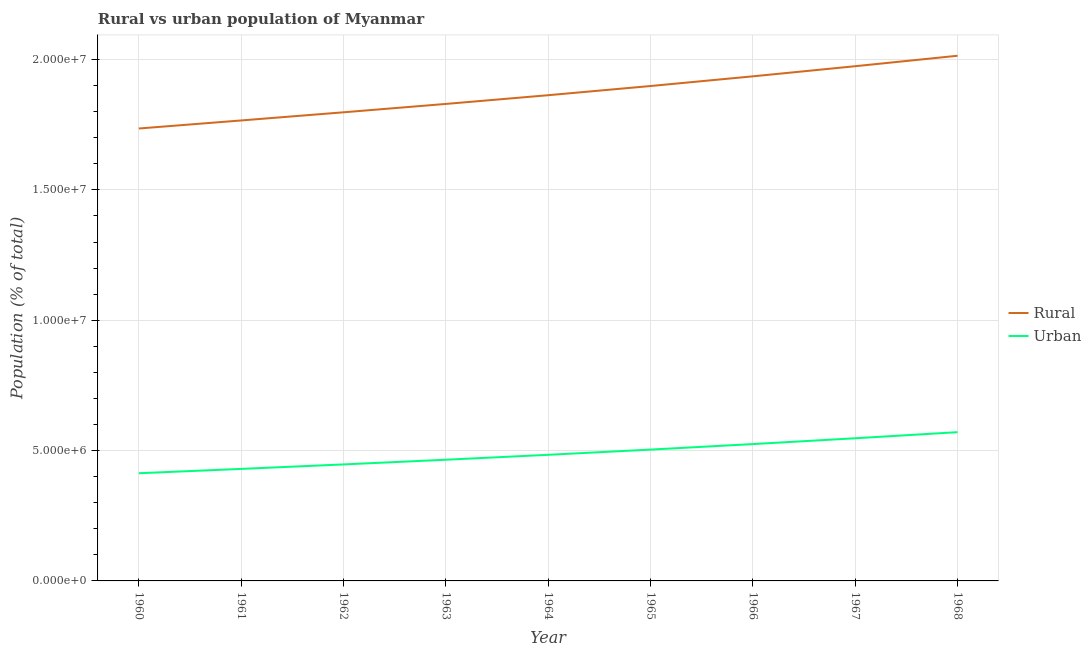Is the number of lines equal to the number of legend labels?
Make the answer very short. Yes. What is the rural population density in 1961?
Your answer should be very brief. 1.77e+07. Across all years, what is the maximum rural population density?
Give a very brief answer. 2.01e+07. Across all years, what is the minimum urban population density?
Keep it short and to the point. 4.13e+06. In which year was the rural population density maximum?
Provide a short and direct response. 1968. What is the total urban population density in the graph?
Give a very brief answer. 4.39e+07. What is the difference between the rural population density in 1964 and that in 1968?
Provide a short and direct response. -1.51e+06. What is the difference between the rural population density in 1967 and the urban population density in 1968?
Provide a succinct answer. 1.40e+07. What is the average urban population density per year?
Offer a terse response. 4.87e+06. In the year 1968, what is the difference between the rural population density and urban population density?
Ensure brevity in your answer.  1.44e+07. What is the ratio of the urban population density in 1960 to that in 1964?
Provide a succinct answer. 0.85. What is the difference between the highest and the second highest urban population density?
Provide a short and direct response. 2.34e+05. What is the difference between the highest and the lowest urban population density?
Provide a succinct answer. 1.58e+06. In how many years, is the urban population density greater than the average urban population density taken over all years?
Keep it short and to the point. 4. Does the rural population density monotonically increase over the years?
Ensure brevity in your answer.  Yes. Is the urban population density strictly greater than the rural population density over the years?
Offer a very short reply. No. What is the difference between two consecutive major ticks on the Y-axis?
Make the answer very short. 5.00e+06. Does the graph contain any zero values?
Offer a very short reply. No. Does the graph contain grids?
Your response must be concise. Yes. How many legend labels are there?
Offer a terse response. 2. How are the legend labels stacked?
Ensure brevity in your answer.  Vertical. What is the title of the graph?
Provide a short and direct response. Rural vs urban population of Myanmar. Does "Official aid received" appear as one of the legend labels in the graph?
Give a very brief answer. No. What is the label or title of the X-axis?
Offer a very short reply. Year. What is the label or title of the Y-axis?
Make the answer very short. Population (% of total). What is the Population (% of total) of Rural in 1960?
Ensure brevity in your answer.  1.74e+07. What is the Population (% of total) of Urban in 1960?
Your answer should be compact. 4.13e+06. What is the Population (% of total) in Rural in 1961?
Offer a very short reply. 1.77e+07. What is the Population (% of total) of Urban in 1961?
Your response must be concise. 4.30e+06. What is the Population (% of total) of Rural in 1962?
Ensure brevity in your answer.  1.80e+07. What is the Population (% of total) of Urban in 1962?
Offer a very short reply. 4.47e+06. What is the Population (% of total) in Rural in 1963?
Ensure brevity in your answer.  1.83e+07. What is the Population (% of total) in Urban in 1963?
Give a very brief answer. 4.65e+06. What is the Population (% of total) of Rural in 1964?
Keep it short and to the point. 1.86e+07. What is the Population (% of total) of Urban in 1964?
Ensure brevity in your answer.  4.84e+06. What is the Population (% of total) of Rural in 1965?
Your response must be concise. 1.90e+07. What is the Population (% of total) in Urban in 1965?
Offer a very short reply. 5.04e+06. What is the Population (% of total) in Rural in 1966?
Your answer should be compact. 1.94e+07. What is the Population (% of total) of Urban in 1966?
Provide a succinct answer. 5.25e+06. What is the Population (% of total) in Rural in 1967?
Keep it short and to the point. 1.97e+07. What is the Population (% of total) in Urban in 1967?
Provide a short and direct response. 5.47e+06. What is the Population (% of total) of Rural in 1968?
Your answer should be compact. 2.01e+07. What is the Population (% of total) of Urban in 1968?
Provide a succinct answer. 5.71e+06. Across all years, what is the maximum Population (% of total) in Rural?
Your response must be concise. 2.01e+07. Across all years, what is the maximum Population (% of total) of Urban?
Provide a succinct answer. 5.71e+06. Across all years, what is the minimum Population (% of total) in Rural?
Your answer should be compact. 1.74e+07. Across all years, what is the minimum Population (% of total) of Urban?
Ensure brevity in your answer.  4.13e+06. What is the total Population (% of total) of Rural in the graph?
Keep it short and to the point. 1.68e+08. What is the total Population (% of total) in Urban in the graph?
Provide a short and direct response. 4.39e+07. What is the difference between the Population (% of total) of Rural in 1960 and that in 1961?
Provide a succinct answer. -3.09e+05. What is the difference between the Population (% of total) in Urban in 1960 and that in 1961?
Provide a short and direct response. -1.66e+05. What is the difference between the Population (% of total) in Rural in 1960 and that in 1962?
Provide a short and direct response. -6.22e+05. What is the difference between the Population (% of total) of Urban in 1960 and that in 1962?
Offer a very short reply. -3.38e+05. What is the difference between the Population (% of total) of Rural in 1960 and that in 1963?
Ensure brevity in your answer.  -9.43e+05. What is the difference between the Population (% of total) of Urban in 1960 and that in 1963?
Your answer should be very brief. -5.18e+05. What is the difference between the Population (% of total) in Rural in 1960 and that in 1964?
Your response must be concise. -1.28e+06. What is the difference between the Population (% of total) of Urban in 1960 and that in 1964?
Ensure brevity in your answer.  -7.07e+05. What is the difference between the Population (% of total) in Rural in 1960 and that in 1965?
Provide a succinct answer. -1.63e+06. What is the difference between the Population (% of total) of Urban in 1960 and that in 1965?
Your response must be concise. -9.07e+05. What is the difference between the Population (% of total) of Rural in 1960 and that in 1966?
Offer a terse response. -2.00e+06. What is the difference between the Population (% of total) in Urban in 1960 and that in 1966?
Keep it short and to the point. -1.12e+06. What is the difference between the Population (% of total) in Rural in 1960 and that in 1967?
Offer a very short reply. -2.39e+06. What is the difference between the Population (% of total) in Urban in 1960 and that in 1967?
Your answer should be compact. -1.34e+06. What is the difference between the Population (% of total) of Rural in 1960 and that in 1968?
Give a very brief answer. -2.79e+06. What is the difference between the Population (% of total) of Urban in 1960 and that in 1968?
Keep it short and to the point. -1.58e+06. What is the difference between the Population (% of total) of Rural in 1961 and that in 1962?
Offer a terse response. -3.13e+05. What is the difference between the Population (% of total) in Urban in 1961 and that in 1962?
Provide a succinct answer. -1.72e+05. What is the difference between the Population (% of total) in Rural in 1961 and that in 1963?
Make the answer very short. -6.34e+05. What is the difference between the Population (% of total) of Urban in 1961 and that in 1963?
Offer a terse response. -3.52e+05. What is the difference between the Population (% of total) of Rural in 1961 and that in 1964?
Ensure brevity in your answer.  -9.68e+05. What is the difference between the Population (% of total) of Urban in 1961 and that in 1964?
Offer a very short reply. -5.41e+05. What is the difference between the Population (% of total) of Rural in 1961 and that in 1965?
Provide a succinct answer. -1.32e+06. What is the difference between the Population (% of total) in Urban in 1961 and that in 1965?
Your response must be concise. -7.41e+05. What is the difference between the Population (% of total) in Rural in 1961 and that in 1966?
Your answer should be compact. -1.69e+06. What is the difference between the Population (% of total) of Urban in 1961 and that in 1966?
Keep it short and to the point. -9.53e+05. What is the difference between the Population (% of total) in Rural in 1961 and that in 1967?
Offer a terse response. -2.08e+06. What is the difference between the Population (% of total) of Urban in 1961 and that in 1967?
Offer a terse response. -1.18e+06. What is the difference between the Population (% of total) of Rural in 1961 and that in 1968?
Keep it short and to the point. -2.48e+06. What is the difference between the Population (% of total) of Urban in 1961 and that in 1968?
Offer a very short reply. -1.41e+06. What is the difference between the Population (% of total) in Rural in 1962 and that in 1963?
Make the answer very short. -3.21e+05. What is the difference between the Population (% of total) of Urban in 1962 and that in 1963?
Your answer should be compact. -1.80e+05. What is the difference between the Population (% of total) in Rural in 1962 and that in 1964?
Provide a short and direct response. -6.55e+05. What is the difference between the Population (% of total) of Urban in 1962 and that in 1964?
Provide a succinct answer. -3.69e+05. What is the difference between the Population (% of total) in Rural in 1962 and that in 1965?
Your answer should be compact. -1.01e+06. What is the difference between the Population (% of total) in Urban in 1962 and that in 1965?
Keep it short and to the point. -5.69e+05. What is the difference between the Population (% of total) of Rural in 1962 and that in 1966?
Provide a succinct answer. -1.38e+06. What is the difference between the Population (% of total) in Urban in 1962 and that in 1966?
Your answer should be very brief. -7.80e+05. What is the difference between the Population (% of total) of Rural in 1962 and that in 1967?
Keep it short and to the point. -1.77e+06. What is the difference between the Population (% of total) of Urban in 1962 and that in 1967?
Your response must be concise. -1.00e+06. What is the difference between the Population (% of total) of Rural in 1962 and that in 1968?
Ensure brevity in your answer.  -2.17e+06. What is the difference between the Population (% of total) of Urban in 1962 and that in 1968?
Offer a terse response. -1.24e+06. What is the difference between the Population (% of total) in Rural in 1963 and that in 1964?
Provide a succinct answer. -3.35e+05. What is the difference between the Population (% of total) in Urban in 1963 and that in 1964?
Your answer should be very brief. -1.89e+05. What is the difference between the Population (% of total) in Rural in 1963 and that in 1965?
Offer a terse response. -6.87e+05. What is the difference between the Population (% of total) in Urban in 1963 and that in 1965?
Ensure brevity in your answer.  -3.89e+05. What is the difference between the Population (% of total) in Rural in 1963 and that in 1966?
Your response must be concise. -1.06e+06. What is the difference between the Population (% of total) of Urban in 1963 and that in 1966?
Provide a succinct answer. -6.01e+05. What is the difference between the Population (% of total) of Rural in 1963 and that in 1967?
Ensure brevity in your answer.  -1.45e+06. What is the difference between the Population (% of total) in Urban in 1963 and that in 1967?
Offer a terse response. -8.24e+05. What is the difference between the Population (% of total) of Rural in 1963 and that in 1968?
Your answer should be very brief. -1.85e+06. What is the difference between the Population (% of total) of Urban in 1963 and that in 1968?
Make the answer very short. -1.06e+06. What is the difference between the Population (% of total) of Rural in 1964 and that in 1965?
Provide a succinct answer. -3.53e+05. What is the difference between the Population (% of total) of Urban in 1964 and that in 1965?
Give a very brief answer. -2.00e+05. What is the difference between the Population (% of total) in Rural in 1964 and that in 1966?
Offer a very short reply. -7.24e+05. What is the difference between the Population (% of total) of Urban in 1964 and that in 1966?
Your response must be concise. -4.12e+05. What is the difference between the Population (% of total) in Rural in 1964 and that in 1967?
Ensure brevity in your answer.  -1.11e+06. What is the difference between the Population (% of total) of Urban in 1964 and that in 1967?
Ensure brevity in your answer.  -6.35e+05. What is the difference between the Population (% of total) of Rural in 1964 and that in 1968?
Ensure brevity in your answer.  -1.51e+06. What is the difference between the Population (% of total) of Urban in 1964 and that in 1968?
Provide a succinct answer. -8.68e+05. What is the difference between the Population (% of total) in Rural in 1965 and that in 1966?
Ensure brevity in your answer.  -3.72e+05. What is the difference between the Population (% of total) of Urban in 1965 and that in 1966?
Ensure brevity in your answer.  -2.12e+05. What is the difference between the Population (% of total) of Rural in 1965 and that in 1967?
Provide a short and direct response. -7.60e+05. What is the difference between the Population (% of total) in Urban in 1965 and that in 1967?
Provide a succinct answer. -4.35e+05. What is the difference between the Population (% of total) of Rural in 1965 and that in 1968?
Provide a succinct answer. -1.16e+06. What is the difference between the Population (% of total) in Urban in 1965 and that in 1968?
Offer a terse response. -6.69e+05. What is the difference between the Population (% of total) in Rural in 1966 and that in 1967?
Your answer should be compact. -3.88e+05. What is the difference between the Population (% of total) in Urban in 1966 and that in 1967?
Keep it short and to the point. -2.23e+05. What is the difference between the Population (% of total) of Rural in 1966 and that in 1968?
Your answer should be very brief. -7.89e+05. What is the difference between the Population (% of total) of Urban in 1966 and that in 1968?
Ensure brevity in your answer.  -4.57e+05. What is the difference between the Population (% of total) of Rural in 1967 and that in 1968?
Ensure brevity in your answer.  -4.01e+05. What is the difference between the Population (% of total) in Urban in 1967 and that in 1968?
Provide a short and direct response. -2.34e+05. What is the difference between the Population (% of total) of Rural in 1960 and the Population (% of total) of Urban in 1961?
Make the answer very short. 1.31e+07. What is the difference between the Population (% of total) in Rural in 1960 and the Population (% of total) in Urban in 1962?
Your answer should be very brief. 1.29e+07. What is the difference between the Population (% of total) of Rural in 1960 and the Population (% of total) of Urban in 1963?
Make the answer very short. 1.27e+07. What is the difference between the Population (% of total) of Rural in 1960 and the Population (% of total) of Urban in 1964?
Keep it short and to the point. 1.25e+07. What is the difference between the Population (% of total) of Rural in 1960 and the Population (% of total) of Urban in 1965?
Your response must be concise. 1.23e+07. What is the difference between the Population (% of total) of Rural in 1960 and the Population (% of total) of Urban in 1966?
Offer a terse response. 1.21e+07. What is the difference between the Population (% of total) in Rural in 1960 and the Population (% of total) in Urban in 1967?
Provide a short and direct response. 1.19e+07. What is the difference between the Population (% of total) of Rural in 1960 and the Population (% of total) of Urban in 1968?
Your answer should be very brief. 1.16e+07. What is the difference between the Population (% of total) in Rural in 1961 and the Population (% of total) in Urban in 1962?
Give a very brief answer. 1.32e+07. What is the difference between the Population (% of total) of Rural in 1961 and the Population (% of total) of Urban in 1963?
Your response must be concise. 1.30e+07. What is the difference between the Population (% of total) in Rural in 1961 and the Population (% of total) in Urban in 1964?
Your response must be concise. 1.28e+07. What is the difference between the Population (% of total) of Rural in 1961 and the Population (% of total) of Urban in 1965?
Ensure brevity in your answer.  1.26e+07. What is the difference between the Population (% of total) of Rural in 1961 and the Population (% of total) of Urban in 1966?
Offer a terse response. 1.24e+07. What is the difference between the Population (% of total) of Rural in 1961 and the Population (% of total) of Urban in 1967?
Give a very brief answer. 1.22e+07. What is the difference between the Population (% of total) in Rural in 1961 and the Population (% of total) in Urban in 1968?
Provide a succinct answer. 1.20e+07. What is the difference between the Population (% of total) of Rural in 1962 and the Population (% of total) of Urban in 1963?
Your answer should be compact. 1.33e+07. What is the difference between the Population (% of total) in Rural in 1962 and the Population (% of total) in Urban in 1964?
Ensure brevity in your answer.  1.31e+07. What is the difference between the Population (% of total) in Rural in 1962 and the Population (% of total) in Urban in 1965?
Give a very brief answer. 1.29e+07. What is the difference between the Population (% of total) of Rural in 1962 and the Population (% of total) of Urban in 1966?
Keep it short and to the point. 1.27e+07. What is the difference between the Population (% of total) in Rural in 1962 and the Population (% of total) in Urban in 1967?
Your answer should be compact. 1.25e+07. What is the difference between the Population (% of total) in Rural in 1962 and the Population (% of total) in Urban in 1968?
Provide a short and direct response. 1.23e+07. What is the difference between the Population (% of total) in Rural in 1963 and the Population (% of total) in Urban in 1964?
Offer a terse response. 1.35e+07. What is the difference between the Population (% of total) of Rural in 1963 and the Population (% of total) of Urban in 1965?
Your answer should be very brief. 1.33e+07. What is the difference between the Population (% of total) in Rural in 1963 and the Population (% of total) in Urban in 1966?
Offer a terse response. 1.30e+07. What is the difference between the Population (% of total) of Rural in 1963 and the Population (% of total) of Urban in 1967?
Provide a short and direct response. 1.28e+07. What is the difference between the Population (% of total) of Rural in 1963 and the Population (% of total) of Urban in 1968?
Offer a very short reply. 1.26e+07. What is the difference between the Population (% of total) of Rural in 1964 and the Population (% of total) of Urban in 1965?
Offer a terse response. 1.36e+07. What is the difference between the Population (% of total) in Rural in 1964 and the Population (% of total) in Urban in 1966?
Provide a succinct answer. 1.34e+07. What is the difference between the Population (% of total) of Rural in 1964 and the Population (% of total) of Urban in 1967?
Ensure brevity in your answer.  1.32e+07. What is the difference between the Population (% of total) in Rural in 1964 and the Population (% of total) in Urban in 1968?
Your response must be concise. 1.29e+07. What is the difference between the Population (% of total) in Rural in 1965 and the Population (% of total) in Urban in 1966?
Provide a succinct answer. 1.37e+07. What is the difference between the Population (% of total) of Rural in 1965 and the Population (% of total) of Urban in 1967?
Provide a succinct answer. 1.35e+07. What is the difference between the Population (% of total) of Rural in 1965 and the Population (% of total) of Urban in 1968?
Your response must be concise. 1.33e+07. What is the difference between the Population (% of total) in Rural in 1966 and the Population (% of total) in Urban in 1967?
Make the answer very short. 1.39e+07. What is the difference between the Population (% of total) in Rural in 1966 and the Population (% of total) in Urban in 1968?
Ensure brevity in your answer.  1.37e+07. What is the difference between the Population (% of total) in Rural in 1967 and the Population (% of total) in Urban in 1968?
Provide a short and direct response. 1.40e+07. What is the average Population (% of total) of Rural per year?
Your answer should be very brief. 1.87e+07. What is the average Population (% of total) of Urban per year?
Ensure brevity in your answer.  4.87e+06. In the year 1960, what is the difference between the Population (% of total) in Rural and Population (% of total) in Urban?
Provide a short and direct response. 1.32e+07. In the year 1961, what is the difference between the Population (% of total) of Rural and Population (% of total) of Urban?
Ensure brevity in your answer.  1.34e+07. In the year 1962, what is the difference between the Population (% of total) in Rural and Population (% of total) in Urban?
Keep it short and to the point. 1.35e+07. In the year 1963, what is the difference between the Population (% of total) in Rural and Population (% of total) in Urban?
Keep it short and to the point. 1.36e+07. In the year 1964, what is the difference between the Population (% of total) in Rural and Population (% of total) in Urban?
Your answer should be very brief. 1.38e+07. In the year 1965, what is the difference between the Population (% of total) of Rural and Population (% of total) of Urban?
Your response must be concise. 1.39e+07. In the year 1966, what is the difference between the Population (% of total) in Rural and Population (% of total) in Urban?
Your answer should be compact. 1.41e+07. In the year 1967, what is the difference between the Population (% of total) in Rural and Population (% of total) in Urban?
Provide a succinct answer. 1.43e+07. In the year 1968, what is the difference between the Population (% of total) in Rural and Population (% of total) in Urban?
Your answer should be compact. 1.44e+07. What is the ratio of the Population (% of total) of Rural in 1960 to that in 1961?
Provide a short and direct response. 0.98. What is the ratio of the Population (% of total) of Urban in 1960 to that in 1961?
Provide a succinct answer. 0.96. What is the ratio of the Population (% of total) of Rural in 1960 to that in 1962?
Offer a very short reply. 0.97. What is the ratio of the Population (% of total) in Urban in 1960 to that in 1962?
Offer a terse response. 0.92. What is the ratio of the Population (% of total) in Rural in 1960 to that in 1963?
Ensure brevity in your answer.  0.95. What is the ratio of the Population (% of total) of Urban in 1960 to that in 1963?
Keep it short and to the point. 0.89. What is the ratio of the Population (% of total) of Rural in 1960 to that in 1964?
Provide a short and direct response. 0.93. What is the ratio of the Population (% of total) in Urban in 1960 to that in 1964?
Keep it short and to the point. 0.85. What is the ratio of the Population (% of total) of Rural in 1960 to that in 1965?
Keep it short and to the point. 0.91. What is the ratio of the Population (% of total) of Urban in 1960 to that in 1965?
Provide a short and direct response. 0.82. What is the ratio of the Population (% of total) of Rural in 1960 to that in 1966?
Offer a very short reply. 0.9. What is the ratio of the Population (% of total) of Urban in 1960 to that in 1966?
Provide a short and direct response. 0.79. What is the ratio of the Population (% of total) of Rural in 1960 to that in 1967?
Offer a very short reply. 0.88. What is the ratio of the Population (% of total) in Urban in 1960 to that in 1967?
Make the answer very short. 0.75. What is the ratio of the Population (% of total) of Rural in 1960 to that in 1968?
Give a very brief answer. 0.86. What is the ratio of the Population (% of total) in Urban in 1960 to that in 1968?
Ensure brevity in your answer.  0.72. What is the ratio of the Population (% of total) in Rural in 1961 to that in 1962?
Offer a very short reply. 0.98. What is the ratio of the Population (% of total) of Urban in 1961 to that in 1962?
Your response must be concise. 0.96. What is the ratio of the Population (% of total) of Rural in 1961 to that in 1963?
Offer a very short reply. 0.97. What is the ratio of the Population (% of total) in Urban in 1961 to that in 1963?
Make the answer very short. 0.92. What is the ratio of the Population (% of total) in Rural in 1961 to that in 1964?
Give a very brief answer. 0.95. What is the ratio of the Population (% of total) in Urban in 1961 to that in 1964?
Your answer should be very brief. 0.89. What is the ratio of the Population (% of total) of Rural in 1961 to that in 1965?
Make the answer very short. 0.93. What is the ratio of the Population (% of total) in Urban in 1961 to that in 1965?
Ensure brevity in your answer.  0.85. What is the ratio of the Population (% of total) of Rural in 1961 to that in 1966?
Provide a short and direct response. 0.91. What is the ratio of the Population (% of total) in Urban in 1961 to that in 1966?
Give a very brief answer. 0.82. What is the ratio of the Population (% of total) in Rural in 1961 to that in 1967?
Make the answer very short. 0.89. What is the ratio of the Population (% of total) of Urban in 1961 to that in 1967?
Offer a very short reply. 0.79. What is the ratio of the Population (% of total) in Rural in 1961 to that in 1968?
Give a very brief answer. 0.88. What is the ratio of the Population (% of total) of Urban in 1961 to that in 1968?
Your response must be concise. 0.75. What is the ratio of the Population (% of total) of Rural in 1962 to that in 1963?
Offer a terse response. 0.98. What is the ratio of the Population (% of total) of Urban in 1962 to that in 1963?
Offer a terse response. 0.96. What is the ratio of the Population (% of total) in Rural in 1962 to that in 1964?
Make the answer very short. 0.96. What is the ratio of the Population (% of total) in Urban in 1962 to that in 1964?
Ensure brevity in your answer.  0.92. What is the ratio of the Population (% of total) in Rural in 1962 to that in 1965?
Your answer should be very brief. 0.95. What is the ratio of the Population (% of total) of Urban in 1962 to that in 1965?
Your answer should be compact. 0.89. What is the ratio of the Population (% of total) in Rural in 1962 to that in 1966?
Your answer should be very brief. 0.93. What is the ratio of the Population (% of total) in Urban in 1962 to that in 1966?
Make the answer very short. 0.85. What is the ratio of the Population (% of total) of Rural in 1962 to that in 1967?
Keep it short and to the point. 0.91. What is the ratio of the Population (% of total) of Urban in 1962 to that in 1967?
Your answer should be compact. 0.82. What is the ratio of the Population (% of total) of Rural in 1962 to that in 1968?
Offer a terse response. 0.89. What is the ratio of the Population (% of total) of Urban in 1962 to that in 1968?
Provide a short and direct response. 0.78. What is the ratio of the Population (% of total) in Urban in 1963 to that in 1964?
Offer a very short reply. 0.96. What is the ratio of the Population (% of total) in Rural in 1963 to that in 1965?
Make the answer very short. 0.96. What is the ratio of the Population (% of total) of Urban in 1963 to that in 1965?
Provide a succinct answer. 0.92. What is the ratio of the Population (% of total) in Rural in 1963 to that in 1966?
Offer a very short reply. 0.95. What is the ratio of the Population (% of total) in Urban in 1963 to that in 1966?
Your answer should be very brief. 0.89. What is the ratio of the Population (% of total) of Rural in 1963 to that in 1967?
Make the answer very short. 0.93. What is the ratio of the Population (% of total) of Urban in 1963 to that in 1967?
Keep it short and to the point. 0.85. What is the ratio of the Population (% of total) in Rural in 1963 to that in 1968?
Your answer should be very brief. 0.91. What is the ratio of the Population (% of total) of Urban in 1963 to that in 1968?
Your response must be concise. 0.81. What is the ratio of the Population (% of total) in Rural in 1964 to that in 1965?
Offer a terse response. 0.98. What is the ratio of the Population (% of total) in Urban in 1964 to that in 1965?
Offer a terse response. 0.96. What is the ratio of the Population (% of total) in Rural in 1964 to that in 1966?
Make the answer very short. 0.96. What is the ratio of the Population (% of total) of Urban in 1964 to that in 1966?
Keep it short and to the point. 0.92. What is the ratio of the Population (% of total) of Rural in 1964 to that in 1967?
Keep it short and to the point. 0.94. What is the ratio of the Population (% of total) of Urban in 1964 to that in 1967?
Offer a terse response. 0.88. What is the ratio of the Population (% of total) in Rural in 1964 to that in 1968?
Your answer should be compact. 0.92. What is the ratio of the Population (% of total) in Urban in 1964 to that in 1968?
Ensure brevity in your answer.  0.85. What is the ratio of the Population (% of total) of Rural in 1965 to that in 1966?
Provide a short and direct response. 0.98. What is the ratio of the Population (% of total) of Urban in 1965 to that in 1966?
Keep it short and to the point. 0.96. What is the ratio of the Population (% of total) of Rural in 1965 to that in 1967?
Your answer should be very brief. 0.96. What is the ratio of the Population (% of total) in Urban in 1965 to that in 1967?
Make the answer very short. 0.92. What is the ratio of the Population (% of total) in Rural in 1965 to that in 1968?
Keep it short and to the point. 0.94. What is the ratio of the Population (% of total) in Urban in 1965 to that in 1968?
Provide a succinct answer. 0.88. What is the ratio of the Population (% of total) in Rural in 1966 to that in 1967?
Make the answer very short. 0.98. What is the ratio of the Population (% of total) of Urban in 1966 to that in 1967?
Your answer should be very brief. 0.96. What is the ratio of the Population (% of total) of Rural in 1966 to that in 1968?
Offer a terse response. 0.96. What is the ratio of the Population (% of total) in Urban in 1966 to that in 1968?
Your response must be concise. 0.92. What is the ratio of the Population (% of total) in Rural in 1967 to that in 1968?
Give a very brief answer. 0.98. What is the difference between the highest and the second highest Population (% of total) of Rural?
Offer a very short reply. 4.01e+05. What is the difference between the highest and the second highest Population (% of total) of Urban?
Ensure brevity in your answer.  2.34e+05. What is the difference between the highest and the lowest Population (% of total) of Rural?
Your response must be concise. 2.79e+06. What is the difference between the highest and the lowest Population (% of total) in Urban?
Your answer should be compact. 1.58e+06. 